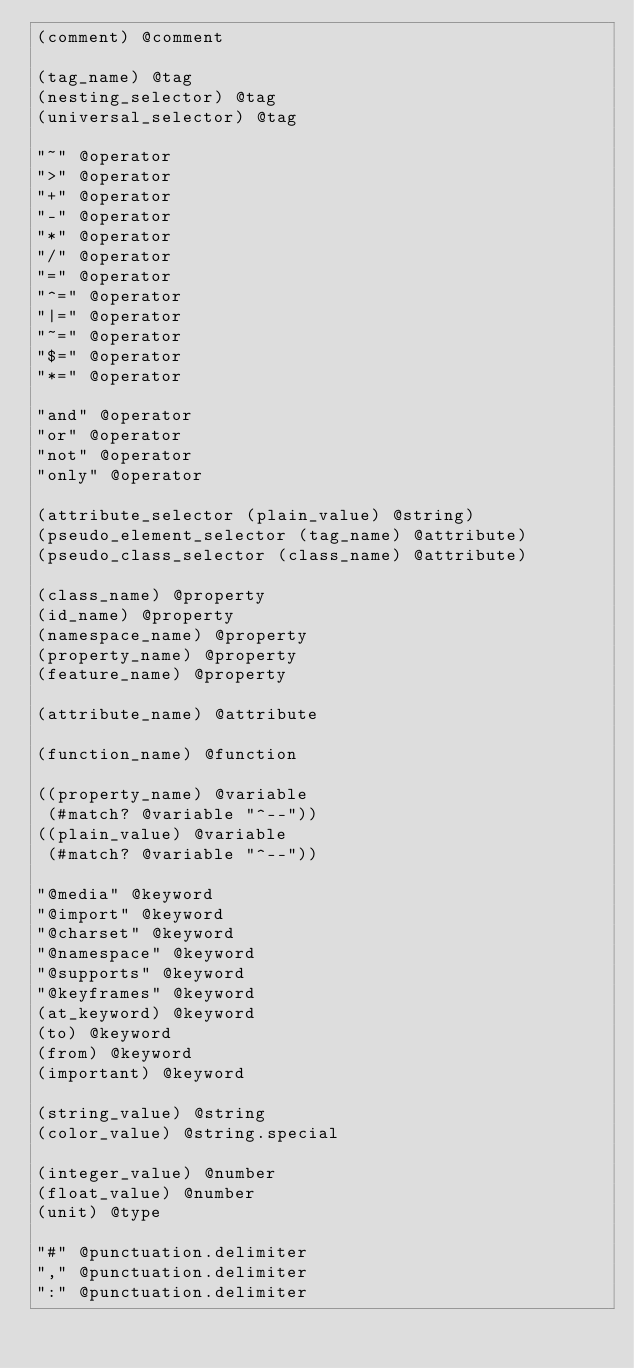Convert code to text. <code><loc_0><loc_0><loc_500><loc_500><_Scheme_>(comment) @comment

(tag_name) @tag
(nesting_selector) @tag
(universal_selector) @tag

"~" @operator
">" @operator
"+" @operator
"-" @operator
"*" @operator
"/" @operator
"=" @operator
"^=" @operator
"|=" @operator
"~=" @operator
"$=" @operator
"*=" @operator

"and" @operator
"or" @operator
"not" @operator
"only" @operator

(attribute_selector (plain_value) @string)
(pseudo_element_selector (tag_name) @attribute)
(pseudo_class_selector (class_name) @attribute)

(class_name) @property
(id_name) @property
(namespace_name) @property
(property_name) @property
(feature_name) @property

(attribute_name) @attribute

(function_name) @function

((property_name) @variable
 (#match? @variable "^--"))
((plain_value) @variable
 (#match? @variable "^--"))

"@media" @keyword
"@import" @keyword
"@charset" @keyword
"@namespace" @keyword
"@supports" @keyword
"@keyframes" @keyword
(at_keyword) @keyword
(to) @keyword
(from) @keyword
(important) @keyword

(string_value) @string
(color_value) @string.special

(integer_value) @number
(float_value) @number
(unit) @type

"#" @punctuation.delimiter
"," @punctuation.delimiter
":" @punctuation.delimiter
</code> 